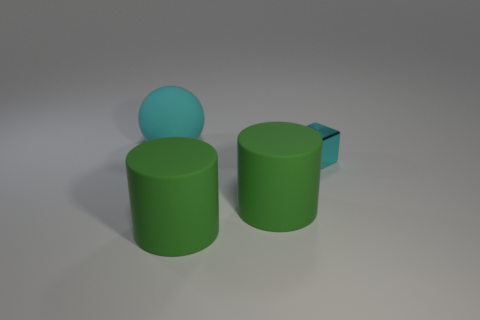Are there any other things that are the same size as the cyan metal thing?
Offer a very short reply. No. Is the large sphere the same color as the metal thing?
Give a very brief answer. Yes. What is the size of the cyan sphere?
Make the answer very short. Large. There is a big cyan rubber object; how many cyan rubber objects are to the left of it?
Offer a very short reply. 0. Is the material of the large object that is behind the cyan metal cube the same as the cyan thing that is in front of the cyan matte sphere?
Offer a very short reply. No. The cyan object that is left of the cyan thing right of the large rubber thing that is behind the tiny cyan object is what shape?
Your answer should be very brief. Sphere. What is the shape of the large cyan object?
Offer a very short reply. Sphere. What number of other things are the same color as the big rubber ball?
Keep it short and to the point. 1. What number of objects are either large objects that are behind the tiny cyan metallic block or cyan objects that are on the left side of the cyan metallic block?
Offer a terse response. 1. How many other things are there of the same material as the big ball?
Make the answer very short. 2. 